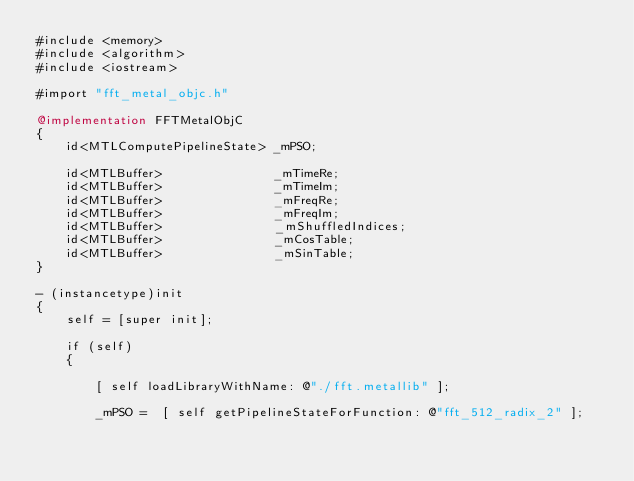Convert code to text. <code><loc_0><loc_0><loc_500><loc_500><_ObjectiveC_>#include <memory>
#include <algorithm>
#include <iostream>

#import "fft_metal_objc.h"

@implementation FFTMetalObjC
{
    id<MTLComputePipelineState> _mPSO;

    id<MTLBuffer>               _mTimeRe;
    id<MTLBuffer>               _mTimeIm;
    id<MTLBuffer>               _mFreqRe;
    id<MTLBuffer>               _mFreqIm;
    id<MTLBuffer>               _mShuffledIndices;
    id<MTLBuffer>               _mCosTable;
    id<MTLBuffer>               _mSinTable;
}

- (instancetype)init
{
    self = [super init];

    if (self)
    {

        [ self loadLibraryWithName: @"./fft.metallib" ];

        _mPSO =  [ self getPipelineStateForFunction: @"fft_512_radix_2" ];
</code> 